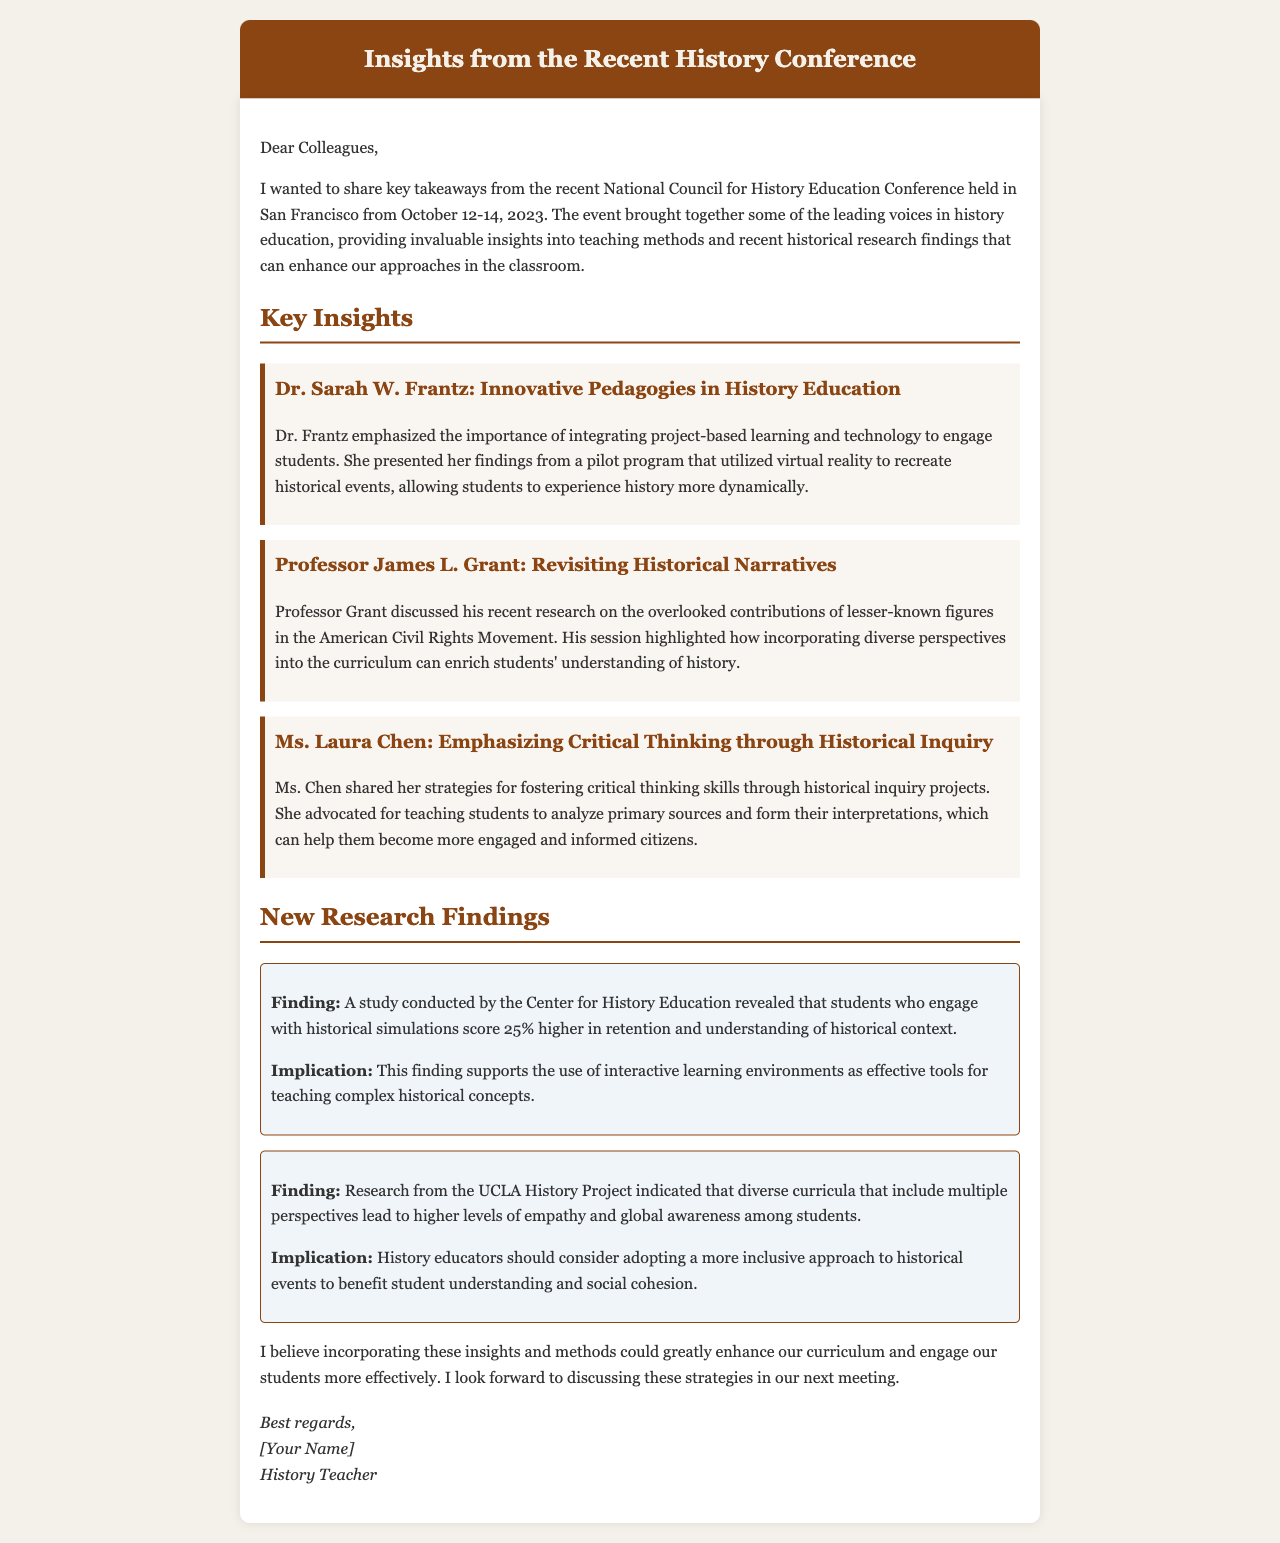What were the dates of the conference? The dates of the conference are explicitly mentioned in the document as October 12-14, 2023.
Answer: October 12-14, 2023 Who emphasized innovative pedagogies in history education? The document lists Dr. Sarah W. Frantz as the speaker who emphasized innovative pedagogies.
Answer: Dr. Sarah W. Frantz Which method did Dr. Frantz suggest for engaging students? Dr. Frantz suggested integrating project-based learning and technology, including virtual reality, to engage students in the past.
Answer: Virtual reality What did Professor Grant focus on in his presentation? Professor Grant's focus was on the overlooked contributions of lesser-known figures in the American Civil Rights Movement.
Answer: Lesser-known figures in the American Civil Rights Movement What percentage increase in retention was noted for students engaging with historical simulations? The document states that students engaged in historical simulations scored 25% higher in retention.
Answer: 25% What implication is associated with diverse curricula according to the UCLA History Project? The implication is that diverse curricula promote higher levels of empathy and global awareness among students.
Answer: Higher levels of empathy and global awareness What does Ms. Chen advocate for in teaching? Ms. Chen advocates for teaching students to analyze primary sources and form their interpretations to enhance engagement.
Answer: Analyzing primary sources What is the main purpose of this document? The main purpose of the document is to summarize insights from a recent history conference for colleagues.
Answer: Summarize insights from a conference 